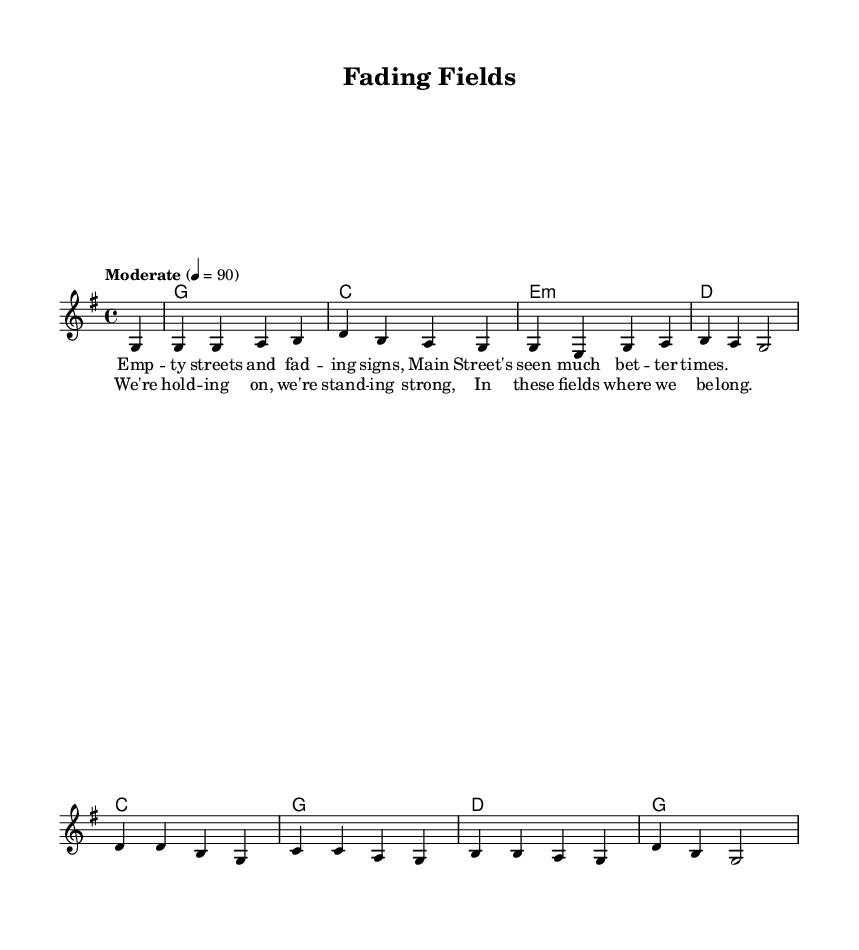What is the key signature of this music? The key signature is indicated at the beginning of the piece and shows one sharp, indicating that the music is in G major.
Answer: G major What is the time signature of this music? The time signature is shown at the beginning and indicates that there are four beats per measure, which is typical for many folk songs.
Answer: 4/4 What is the tempo marking of this piece? The tempo marking is provided in the score and specifies a moderate speed of 90 beats per minute.
Answer: Moderate 4 = 90 How many measures are in the melody? By counting the measures in the melody section, we find there are eight measures in total, as represented in the notation.
Answer: 8 What are the lyrics of the chorus? The lyrics can be found in the lyric section associated with the melody, repeating the central theme of hope and belonging in rural communities.
Answer: We're holding on, we're standing strong, In these fields where we belong What is the chord progression for the first verse? The chord progression is notated directly above the melody line. Starting with G for one measure, it moves to C, E minor, and D for the following measures.
Answer: G, C, E minor, D How do the lyrics reflect the themes of contemporary Americana folk? The lyrics address typical challenges faced by rural communities, such as declining populations and a sense of longing for better times, encapsulating the folk genre's focus on personal stories.
Answer: Reflect struggles and resilience 